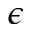Convert formula to latex. <formula><loc_0><loc_0><loc_500><loc_500>\epsilon</formula> 